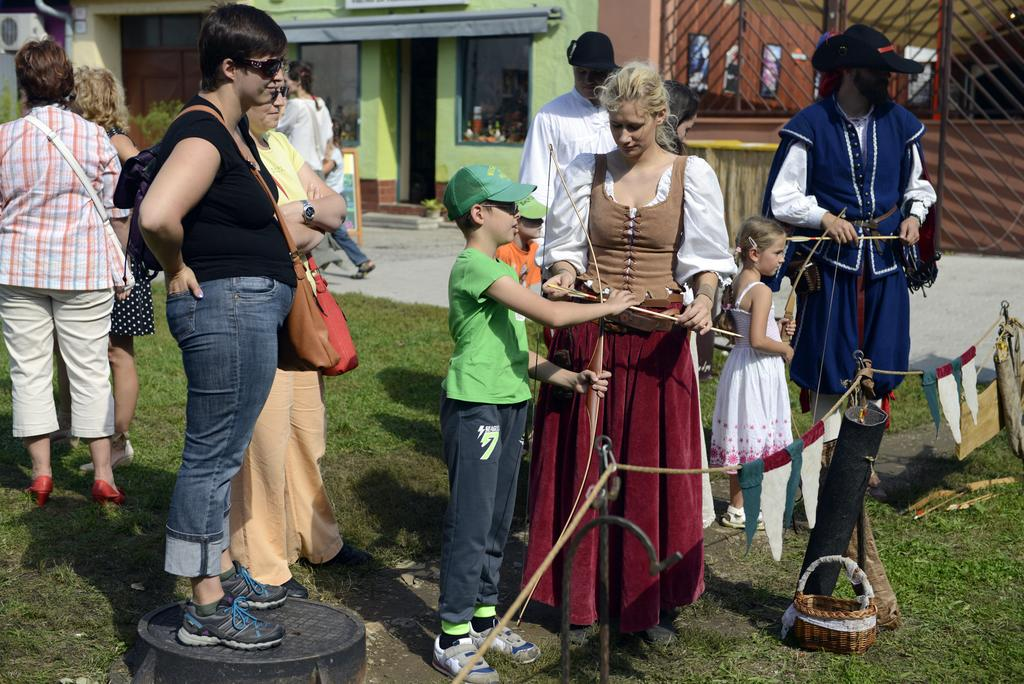What can be seen in the image? There are people standing in the image. What is at the bottom of the image? There is a fence at the bottom of the image. What is placed on the grass in the image? A basket is placed on the grass in the image. What can be seen in the distance in the image? There are buildings in the background of the image. What is the rate at which the boy is pointing in the image? There is no boy present in the image, and therefore no one is pointing. 